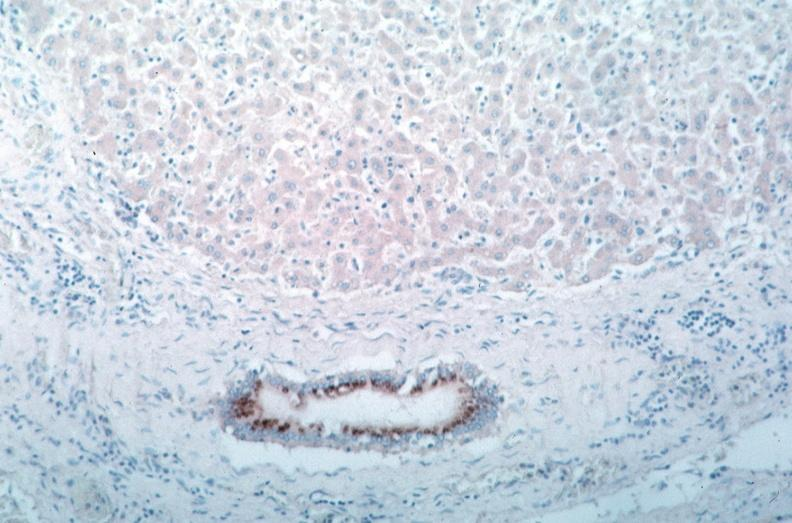what is present?
Answer the question using a single word or phrase. Vasculature 